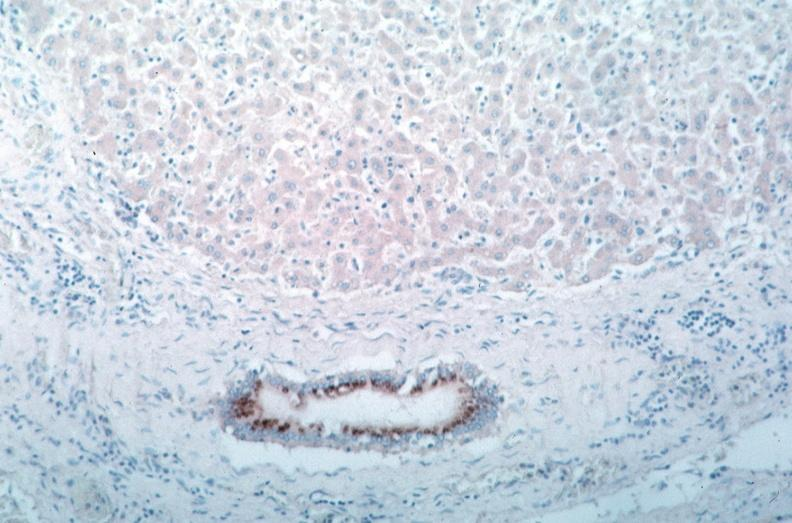what is present?
Answer the question using a single word or phrase. Vasculature 